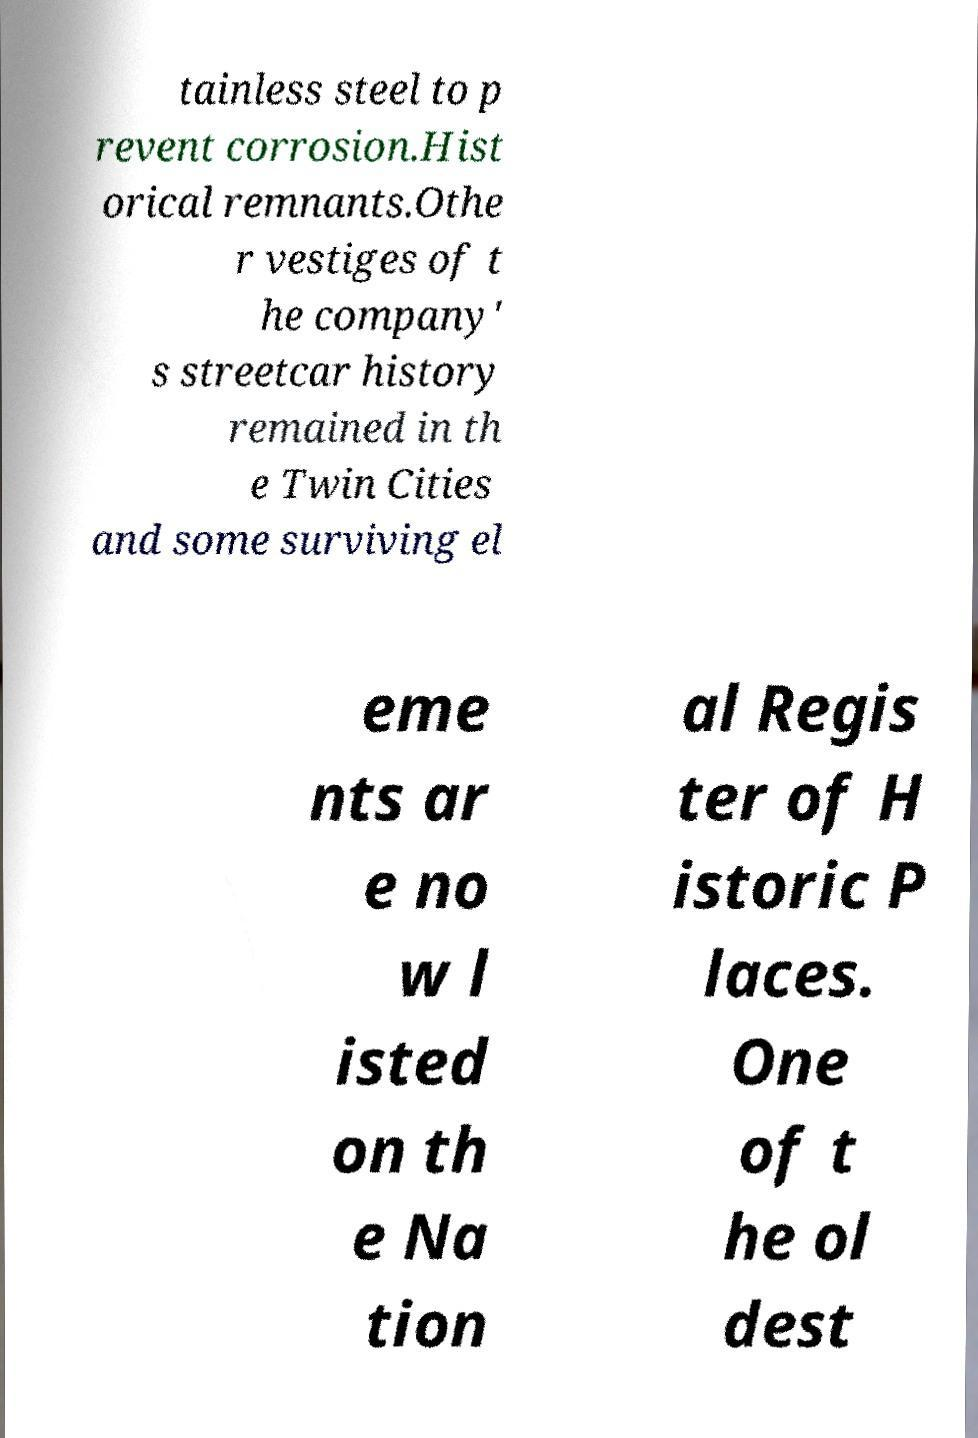Can you read and provide the text displayed in the image?This photo seems to have some interesting text. Can you extract and type it out for me? tainless steel to p revent corrosion.Hist orical remnants.Othe r vestiges of t he company' s streetcar history remained in th e Twin Cities and some surviving el eme nts ar e no w l isted on th e Na tion al Regis ter of H istoric P laces. One of t he ol dest 